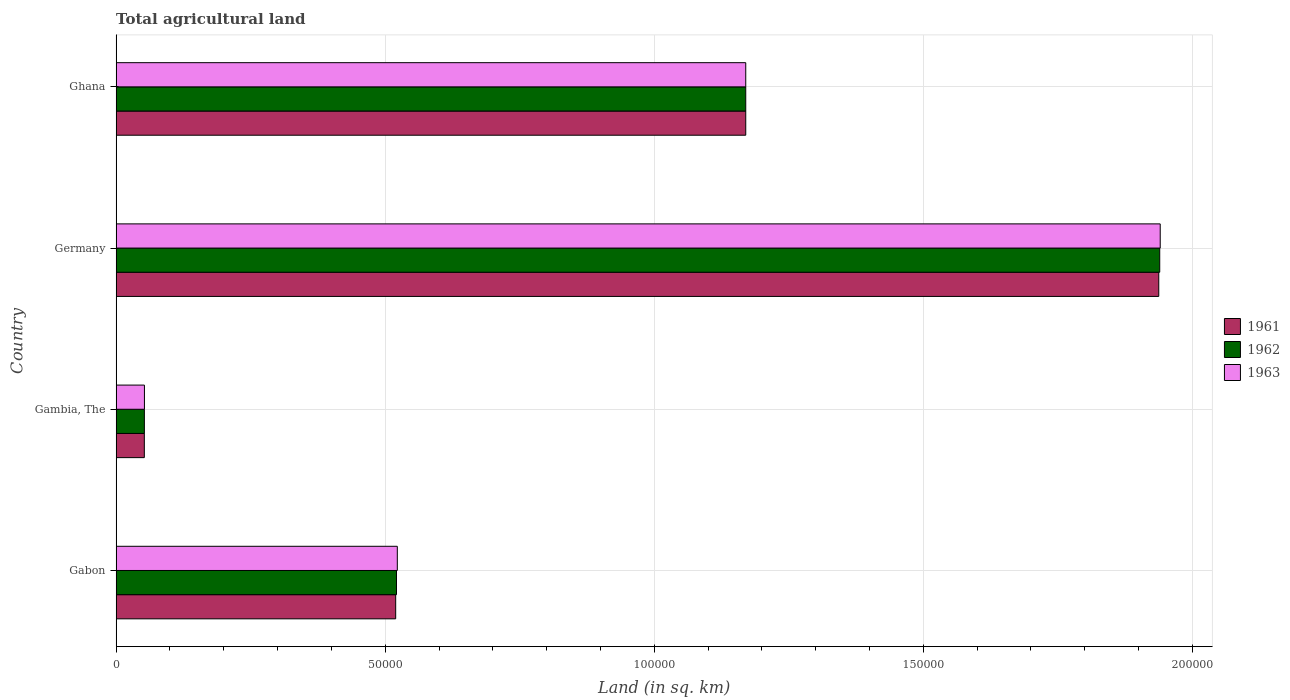How many different coloured bars are there?
Keep it short and to the point. 3. Are the number of bars on each tick of the Y-axis equal?
Provide a short and direct response. Yes. How many bars are there on the 3rd tick from the top?
Keep it short and to the point. 3. What is the total agricultural land in 1962 in Ghana?
Ensure brevity in your answer.  1.17e+05. Across all countries, what is the maximum total agricultural land in 1963?
Offer a very short reply. 1.94e+05. Across all countries, what is the minimum total agricultural land in 1961?
Provide a short and direct response. 5240. In which country was the total agricultural land in 1962 minimum?
Make the answer very short. Gambia, The. What is the total total agricultural land in 1962 in the graph?
Keep it short and to the point. 3.68e+05. What is the difference between the total agricultural land in 1962 in Gambia, The and that in Germany?
Make the answer very short. -1.89e+05. What is the difference between the total agricultural land in 1962 in Gambia, The and the total agricultural land in 1963 in Gabon?
Offer a terse response. -4.70e+04. What is the average total agricultural land in 1962 per country?
Your answer should be compact. 9.21e+04. What is the difference between the total agricultural land in 1962 and total agricultural land in 1963 in Gabon?
Make the answer very short. -150. In how many countries, is the total agricultural land in 1962 greater than 90000 sq.km?
Provide a short and direct response. 2. What is the ratio of the total agricultural land in 1963 in Gambia, The to that in Germany?
Provide a short and direct response. 0.03. Is the total agricultural land in 1962 in Gambia, The less than that in Ghana?
Offer a terse response. Yes. Is the difference between the total agricultural land in 1962 in Gabon and Ghana greater than the difference between the total agricultural land in 1963 in Gabon and Ghana?
Ensure brevity in your answer.  No. What is the difference between the highest and the second highest total agricultural land in 1961?
Make the answer very short. 7.68e+04. What is the difference between the highest and the lowest total agricultural land in 1961?
Keep it short and to the point. 1.89e+05. Is the sum of the total agricultural land in 1962 in Gabon and Ghana greater than the maximum total agricultural land in 1961 across all countries?
Your response must be concise. No. What does the 2nd bar from the top in Germany represents?
Your response must be concise. 1962. Is it the case that in every country, the sum of the total agricultural land in 1961 and total agricultural land in 1963 is greater than the total agricultural land in 1962?
Your answer should be compact. Yes. Are all the bars in the graph horizontal?
Offer a terse response. Yes. What is the difference between two consecutive major ticks on the X-axis?
Your answer should be very brief. 5.00e+04. Are the values on the major ticks of X-axis written in scientific E-notation?
Provide a short and direct response. No. Does the graph contain any zero values?
Provide a succinct answer. No. Where does the legend appear in the graph?
Offer a very short reply. Center right. What is the title of the graph?
Offer a terse response. Total agricultural land. Does "2001" appear as one of the legend labels in the graph?
Your answer should be compact. No. What is the label or title of the X-axis?
Ensure brevity in your answer.  Land (in sq. km). What is the Land (in sq. km) of 1961 in Gabon?
Give a very brief answer. 5.20e+04. What is the Land (in sq. km) in 1962 in Gabon?
Provide a succinct answer. 5.21e+04. What is the Land (in sq. km) of 1963 in Gabon?
Keep it short and to the point. 5.22e+04. What is the Land (in sq. km) in 1961 in Gambia, The?
Offer a very short reply. 5240. What is the Land (in sq. km) in 1962 in Gambia, The?
Offer a terse response. 5250. What is the Land (in sq. km) in 1963 in Gambia, The?
Offer a very short reply. 5260. What is the Land (in sq. km) in 1961 in Germany?
Your answer should be very brief. 1.94e+05. What is the Land (in sq. km) of 1962 in Germany?
Make the answer very short. 1.94e+05. What is the Land (in sq. km) in 1963 in Germany?
Offer a very short reply. 1.94e+05. What is the Land (in sq. km) in 1961 in Ghana?
Provide a succinct answer. 1.17e+05. What is the Land (in sq. km) of 1962 in Ghana?
Offer a very short reply. 1.17e+05. What is the Land (in sq. km) of 1963 in Ghana?
Offer a very short reply. 1.17e+05. Across all countries, what is the maximum Land (in sq. km) of 1961?
Offer a terse response. 1.94e+05. Across all countries, what is the maximum Land (in sq. km) in 1962?
Give a very brief answer. 1.94e+05. Across all countries, what is the maximum Land (in sq. km) of 1963?
Offer a very short reply. 1.94e+05. Across all countries, what is the minimum Land (in sq. km) in 1961?
Offer a very short reply. 5240. Across all countries, what is the minimum Land (in sq. km) of 1962?
Offer a very short reply. 5250. Across all countries, what is the minimum Land (in sq. km) in 1963?
Keep it short and to the point. 5260. What is the total Land (in sq. km) of 1961 in the graph?
Your answer should be compact. 3.68e+05. What is the total Land (in sq. km) in 1962 in the graph?
Make the answer very short. 3.68e+05. What is the total Land (in sq. km) of 1963 in the graph?
Offer a terse response. 3.69e+05. What is the difference between the Land (in sq. km) in 1961 in Gabon and that in Gambia, The?
Your response must be concise. 4.67e+04. What is the difference between the Land (in sq. km) of 1962 in Gabon and that in Gambia, The?
Your answer should be compact. 4.68e+04. What is the difference between the Land (in sq. km) of 1963 in Gabon and that in Gambia, The?
Keep it short and to the point. 4.70e+04. What is the difference between the Land (in sq. km) in 1961 in Gabon and that in Germany?
Ensure brevity in your answer.  -1.42e+05. What is the difference between the Land (in sq. km) in 1962 in Gabon and that in Germany?
Provide a short and direct response. -1.42e+05. What is the difference between the Land (in sq. km) in 1963 in Gabon and that in Germany?
Your answer should be compact. -1.42e+05. What is the difference between the Land (in sq. km) in 1961 in Gabon and that in Ghana?
Make the answer very short. -6.50e+04. What is the difference between the Land (in sq. km) of 1962 in Gabon and that in Ghana?
Ensure brevity in your answer.  -6.49e+04. What is the difference between the Land (in sq. km) of 1963 in Gabon and that in Ghana?
Give a very brief answer. -6.48e+04. What is the difference between the Land (in sq. km) of 1961 in Gambia, The and that in Germany?
Provide a short and direct response. -1.89e+05. What is the difference between the Land (in sq. km) in 1962 in Gambia, The and that in Germany?
Keep it short and to the point. -1.89e+05. What is the difference between the Land (in sq. km) of 1963 in Gambia, The and that in Germany?
Make the answer very short. -1.89e+05. What is the difference between the Land (in sq. km) of 1961 in Gambia, The and that in Ghana?
Keep it short and to the point. -1.12e+05. What is the difference between the Land (in sq. km) in 1962 in Gambia, The and that in Ghana?
Your answer should be compact. -1.12e+05. What is the difference between the Land (in sq. km) in 1963 in Gambia, The and that in Ghana?
Ensure brevity in your answer.  -1.12e+05. What is the difference between the Land (in sq. km) of 1961 in Germany and that in Ghana?
Give a very brief answer. 7.68e+04. What is the difference between the Land (in sq. km) in 1962 in Germany and that in Ghana?
Make the answer very short. 7.69e+04. What is the difference between the Land (in sq. km) in 1963 in Germany and that in Ghana?
Your answer should be compact. 7.70e+04. What is the difference between the Land (in sq. km) in 1961 in Gabon and the Land (in sq. km) in 1962 in Gambia, The?
Ensure brevity in your answer.  4.67e+04. What is the difference between the Land (in sq. km) in 1961 in Gabon and the Land (in sq. km) in 1963 in Gambia, The?
Offer a terse response. 4.67e+04. What is the difference between the Land (in sq. km) in 1962 in Gabon and the Land (in sq. km) in 1963 in Gambia, The?
Make the answer very short. 4.68e+04. What is the difference between the Land (in sq. km) of 1961 in Gabon and the Land (in sq. km) of 1962 in Germany?
Ensure brevity in your answer.  -1.42e+05. What is the difference between the Land (in sq. km) in 1961 in Gabon and the Land (in sq. km) in 1963 in Germany?
Offer a terse response. -1.42e+05. What is the difference between the Land (in sq. km) in 1962 in Gabon and the Land (in sq. km) in 1963 in Germany?
Make the answer very short. -1.42e+05. What is the difference between the Land (in sq. km) of 1961 in Gabon and the Land (in sq. km) of 1962 in Ghana?
Make the answer very short. -6.50e+04. What is the difference between the Land (in sq. km) in 1961 in Gabon and the Land (in sq. km) in 1963 in Ghana?
Provide a short and direct response. -6.50e+04. What is the difference between the Land (in sq. km) in 1962 in Gabon and the Land (in sq. km) in 1963 in Ghana?
Offer a terse response. -6.49e+04. What is the difference between the Land (in sq. km) of 1961 in Gambia, The and the Land (in sq. km) of 1962 in Germany?
Give a very brief answer. -1.89e+05. What is the difference between the Land (in sq. km) in 1961 in Gambia, The and the Land (in sq. km) in 1963 in Germany?
Provide a succinct answer. -1.89e+05. What is the difference between the Land (in sq. km) in 1962 in Gambia, The and the Land (in sq. km) in 1963 in Germany?
Ensure brevity in your answer.  -1.89e+05. What is the difference between the Land (in sq. km) in 1961 in Gambia, The and the Land (in sq. km) in 1962 in Ghana?
Keep it short and to the point. -1.12e+05. What is the difference between the Land (in sq. km) of 1961 in Gambia, The and the Land (in sq. km) of 1963 in Ghana?
Your response must be concise. -1.12e+05. What is the difference between the Land (in sq. km) in 1962 in Gambia, The and the Land (in sq. km) in 1963 in Ghana?
Provide a short and direct response. -1.12e+05. What is the difference between the Land (in sq. km) of 1961 in Germany and the Land (in sq. km) of 1962 in Ghana?
Provide a succinct answer. 7.68e+04. What is the difference between the Land (in sq. km) of 1961 in Germany and the Land (in sq. km) of 1963 in Ghana?
Keep it short and to the point. 7.68e+04. What is the difference between the Land (in sq. km) in 1962 in Germany and the Land (in sq. km) in 1963 in Ghana?
Offer a terse response. 7.69e+04. What is the average Land (in sq. km) in 1961 per country?
Your answer should be very brief. 9.20e+04. What is the average Land (in sq. km) in 1962 per country?
Your response must be concise. 9.21e+04. What is the average Land (in sq. km) in 1963 per country?
Your answer should be very brief. 9.21e+04. What is the difference between the Land (in sq. km) of 1961 and Land (in sq. km) of 1962 in Gabon?
Offer a terse response. -150. What is the difference between the Land (in sq. km) in 1961 and Land (in sq. km) in 1963 in Gabon?
Offer a very short reply. -300. What is the difference between the Land (in sq. km) in 1962 and Land (in sq. km) in 1963 in Gabon?
Offer a terse response. -150. What is the difference between the Land (in sq. km) in 1961 and Land (in sq. km) in 1963 in Gambia, The?
Provide a succinct answer. -20. What is the difference between the Land (in sq. km) of 1962 and Land (in sq. km) of 1963 in Gambia, The?
Give a very brief answer. -10. What is the difference between the Land (in sq. km) of 1961 and Land (in sq. km) of 1962 in Germany?
Keep it short and to the point. -180. What is the difference between the Land (in sq. km) of 1961 and Land (in sq. km) of 1963 in Germany?
Provide a short and direct response. -270. What is the difference between the Land (in sq. km) in 1962 and Land (in sq. km) in 1963 in Germany?
Your answer should be very brief. -90. What is the difference between the Land (in sq. km) in 1961 and Land (in sq. km) in 1962 in Ghana?
Ensure brevity in your answer.  0. What is the difference between the Land (in sq. km) of 1961 and Land (in sq. km) of 1963 in Ghana?
Keep it short and to the point. 0. What is the ratio of the Land (in sq. km) in 1961 in Gabon to that in Gambia, The?
Ensure brevity in your answer.  9.91. What is the ratio of the Land (in sq. km) in 1962 in Gabon to that in Gambia, The?
Make the answer very short. 9.92. What is the ratio of the Land (in sq. km) in 1963 in Gabon to that in Gambia, The?
Your answer should be compact. 9.93. What is the ratio of the Land (in sq. km) of 1961 in Gabon to that in Germany?
Your response must be concise. 0.27. What is the ratio of the Land (in sq. km) in 1962 in Gabon to that in Germany?
Your answer should be compact. 0.27. What is the ratio of the Land (in sq. km) in 1963 in Gabon to that in Germany?
Ensure brevity in your answer.  0.27. What is the ratio of the Land (in sq. km) in 1961 in Gabon to that in Ghana?
Offer a very short reply. 0.44. What is the ratio of the Land (in sq. km) of 1962 in Gabon to that in Ghana?
Provide a short and direct response. 0.45. What is the ratio of the Land (in sq. km) of 1963 in Gabon to that in Ghana?
Your answer should be compact. 0.45. What is the ratio of the Land (in sq. km) in 1961 in Gambia, The to that in Germany?
Give a very brief answer. 0.03. What is the ratio of the Land (in sq. km) of 1962 in Gambia, The to that in Germany?
Keep it short and to the point. 0.03. What is the ratio of the Land (in sq. km) of 1963 in Gambia, The to that in Germany?
Your response must be concise. 0.03. What is the ratio of the Land (in sq. km) of 1961 in Gambia, The to that in Ghana?
Your answer should be compact. 0.04. What is the ratio of the Land (in sq. km) of 1962 in Gambia, The to that in Ghana?
Your answer should be compact. 0.04. What is the ratio of the Land (in sq. km) of 1963 in Gambia, The to that in Ghana?
Provide a succinct answer. 0.04. What is the ratio of the Land (in sq. km) of 1961 in Germany to that in Ghana?
Your answer should be very brief. 1.66. What is the ratio of the Land (in sq. km) in 1962 in Germany to that in Ghana?
Ensure brevity in your answer.  1.66. What is the ratio of the Land (in sq. km) in 1963 in Germany to that in Ghana?
Provide a succinct answer. 1.66. What is the difference between the highest and the second highest Land (in sq. km) in 1961?
Ensure brevity in your answer.  7.68e+04. What is the difference between the highest and the second highest Land (in sq. km) in 1962?
Your answer should be compact. 7.69e+04. What is the difference between the highest and the second highest Land (in sq. km) of 1963?
Offer a very short reply. 7.70e+04. What is the difference between the highest and the lowest Land (in sq. km) in 1961?
Provide a short and direct response. 1.89e+05. What is the difference between the highest and the lowest Land (in sq. km) in 1962?
Your answer should be very brief. 1.89e+05. What is the difference between the highest and the lowest Land (in sq. km) of 1963?
Provide a short and direct response. 1.89e+05. 